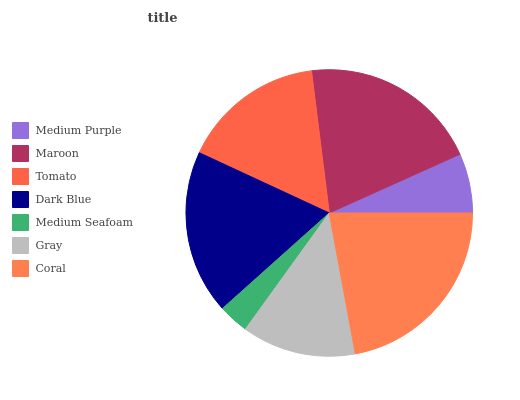Is Medium Seafoam the minimum?
Answer yes or no. Yes. Is Coral the maximum?
Answer yes or no. Yes. Is Maroon the minimum?
Answer yes or no. No. Is Maroon the maximum?
Answer yes or no. No. Is Maroon greater than Medium Purple?
Answer yes or no. Yes. Is Medium Purple less than Maroon?
Answer yes or no. Yes. Is Medium Purple greater than Maroon?
Answer yes or no. No. Is Maroon less than Medium Purple?
Answer yes or no. No. Is Tomato the high median?
Answer yes or no. Yes. Is Tomato the low median?
Answer yes or no. Yes. Is Maroon the high median?
Answer yes or no. No. Is Coral the low median?
Answer yes or no. No. 